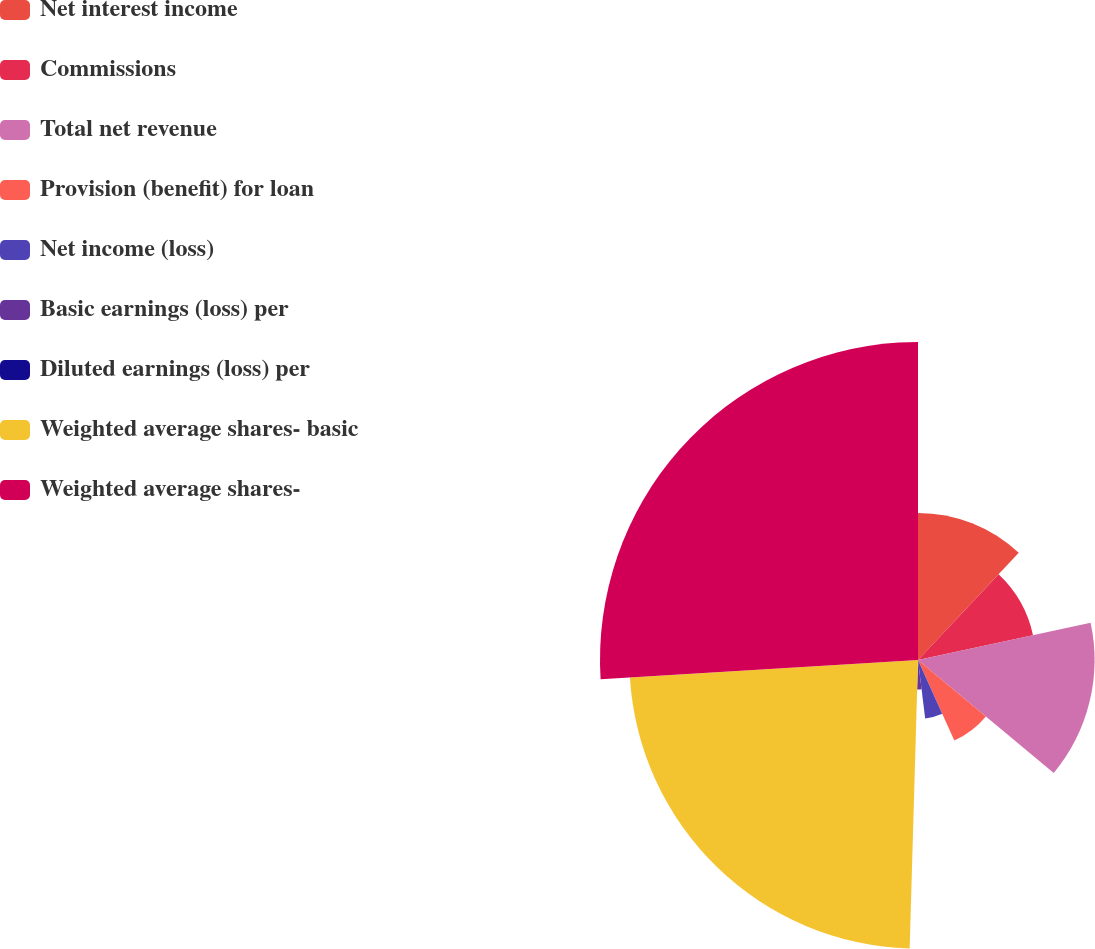Convert chart. <chart><loc_0><loc_0><loc_500><loc_500><pie_chart><fcel>Net interest income<fcel>Commissions<fcel>Total net revenue<fcel>Provision (benefit) for loan<fcel>Net income (loss)<fcel>Basic earnings (loss) per<fcel>Diluted earnings (loss) per<fcel>Weighted average shares- basic<fcel>Weighted average shares-<nl><fcel>12.01%<fcel>9.61%<fcel>14.42%<fcel>7.21%<fcel>4.81%<fcel>2.4%<fcel>0.0%<fcel>23.57%<fcel>25.97%<nl></chart> 